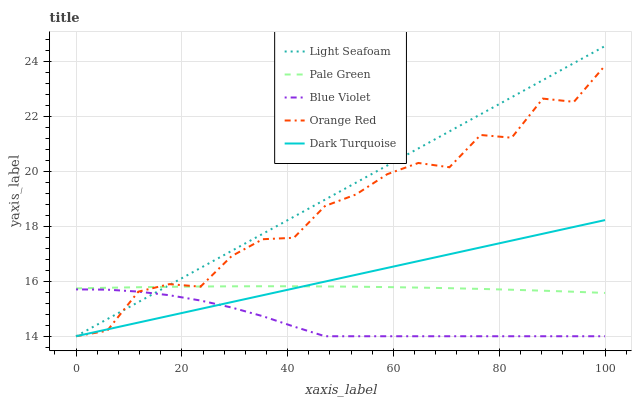Does Blue Violet have the minimum area under the curve?
Answer yes or no. Yes. Does Light Seafoam have the maximum area under the curve?
Answer yes or no. Yes. Does Orange Red have the minimum area under the curve?
Answer yes or no. No. Does Orange Red have the maximum area under the curve?
Answer yes or no. No. Is Dark Turquoise the smoothest?
Answer yes or no. Yes. Is Orange Red the roughest?
Answer yes or no. Yes. Is Light Seafoam the smoothest?
Answer yes or no. No. Is Light Seafoam the roughest?
Answer yes or no. No. Does Light Seafoam have the lowest value?
Answer yes or no. Yes. Does Light Seafoam have the highest value?
Answer yes or no. Yes. Does Orange Red have the highest value?
Answer yes or no. No. Is Blue Violet less than Pale Green?
Answer yes or no. Yes. Is Pale Green greater than Blue Violet?
Answer yes or no. Yes. Does Light Seafoam intersect Dark Turquoise?
Answer yes or no. Yes. Is Light Seafoam less than Dark Turquoise?
Answer yes or no. No. Is Light Seafoam greater than Dark Turquoise?
Answer yes or no. No. Does Blue Violet intersect Pale Green?
Answer yes or no. No. 